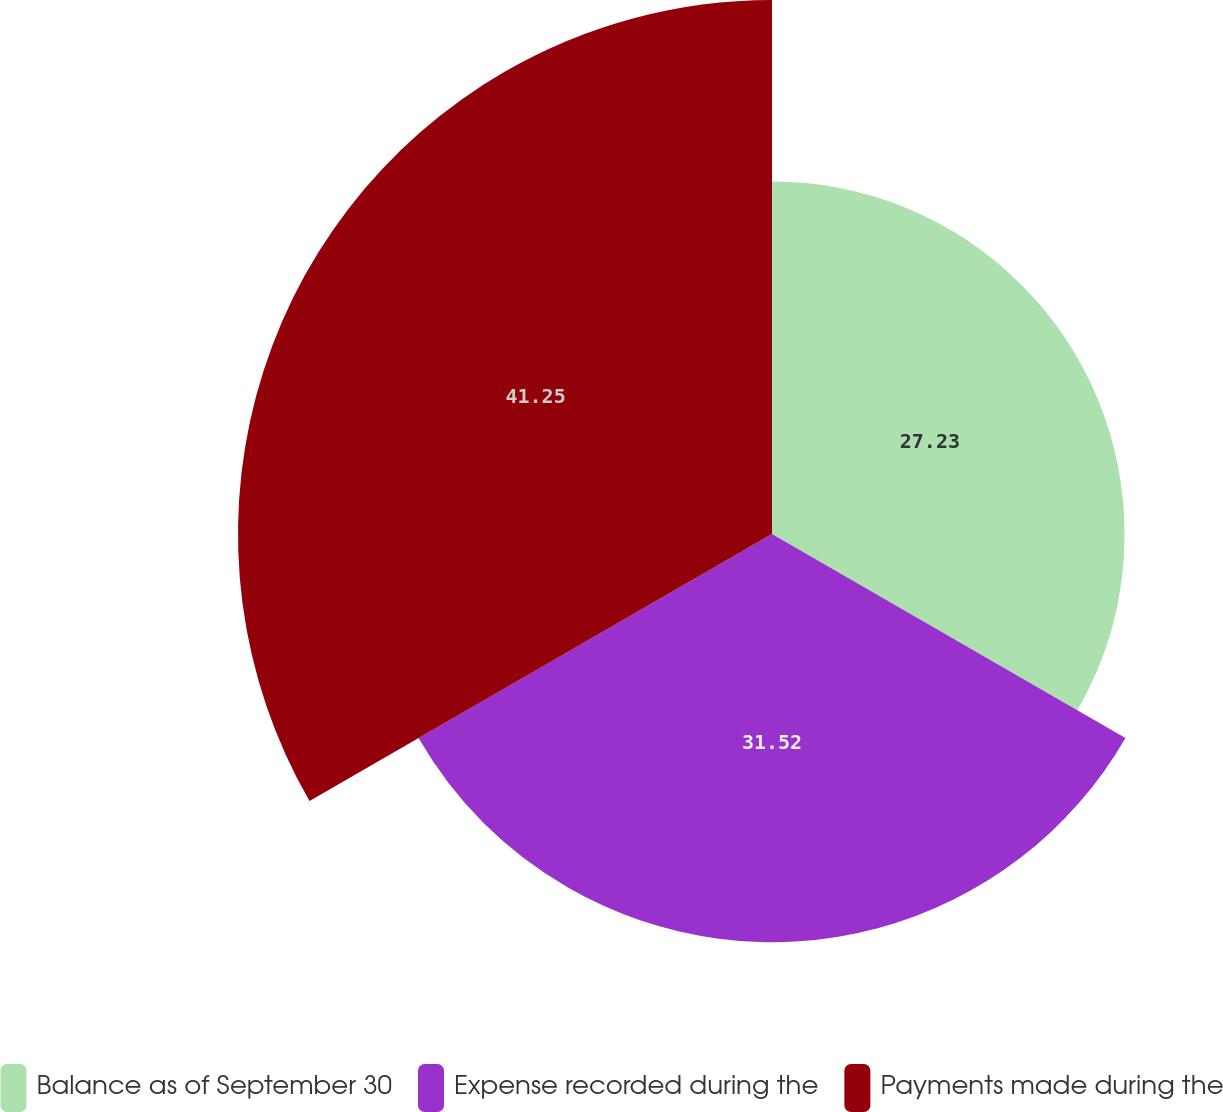Convert chart. <chart><loc_0><loc_0><loc_500><loc_500><pie_chart><fcel>Balance as of September 30<fcel>Expense recorded during the<fcel>Payments made during the<nl><fcel>27.23%<fcel>31.52%<fcel>41.24%<nl></chart> 